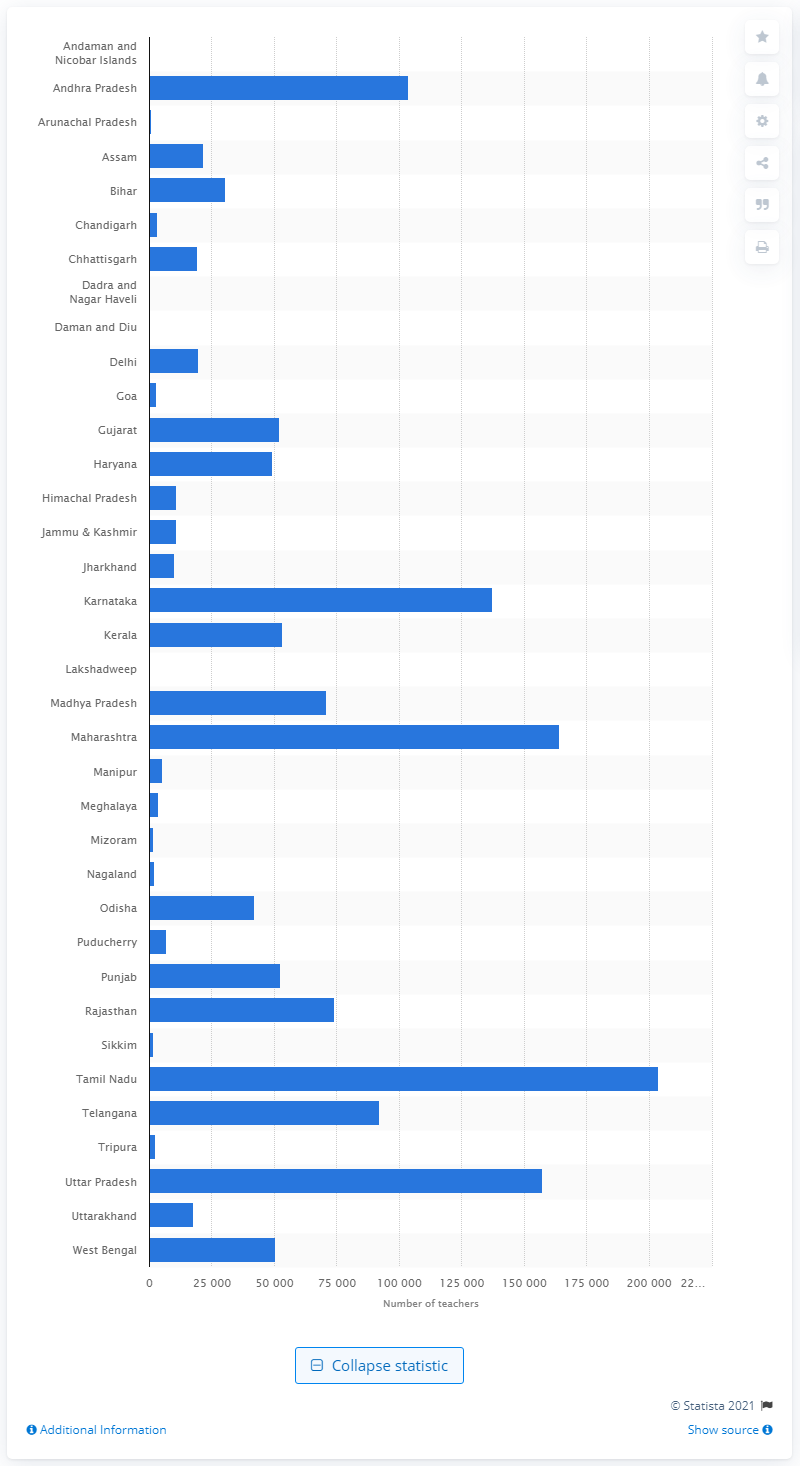Give some essential details in this illustration. Uttar Pradesh had the least number of university and college teachers among all states in India. Lakshadweep was the union territory with the least number of university and college teachers in 2015. 